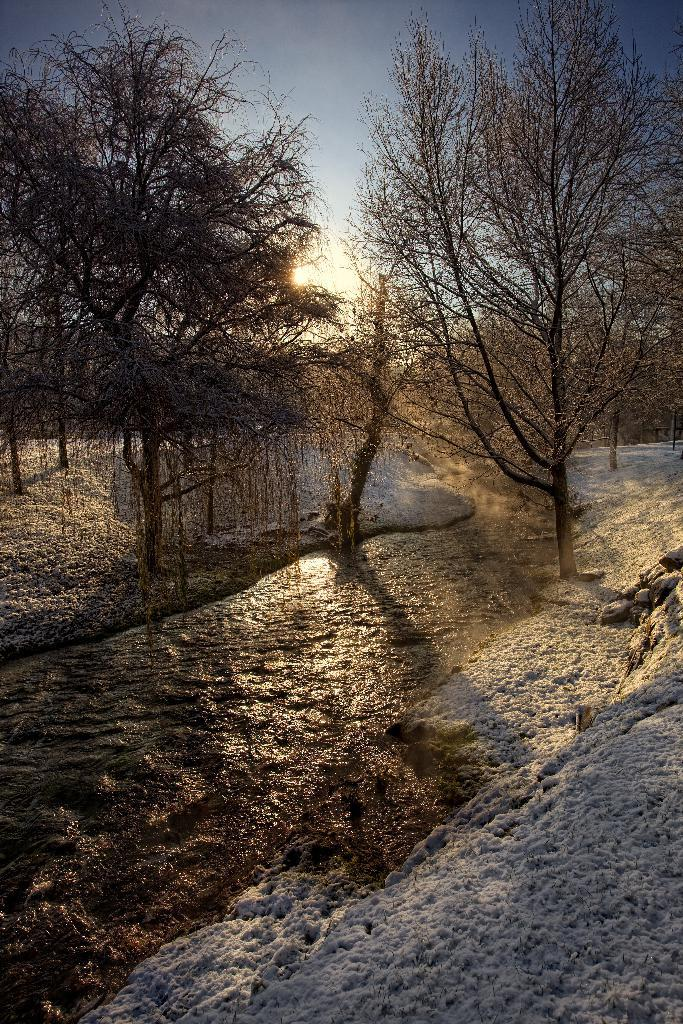What is visible in the image? There is water, a group of trees, and the sun visible in the sky in the image. Can you describe the water in the image? The water is visible, but its specific characteristics are not mentioned in the facts. What is the condition of the sky in the image? The sky is visible, and the sun is visible in the sky in the image. What color is the ink used to write the word "playground" in the image? There is no mention of ink or the word "playground" in the image, so it is not possible to answer this question. 